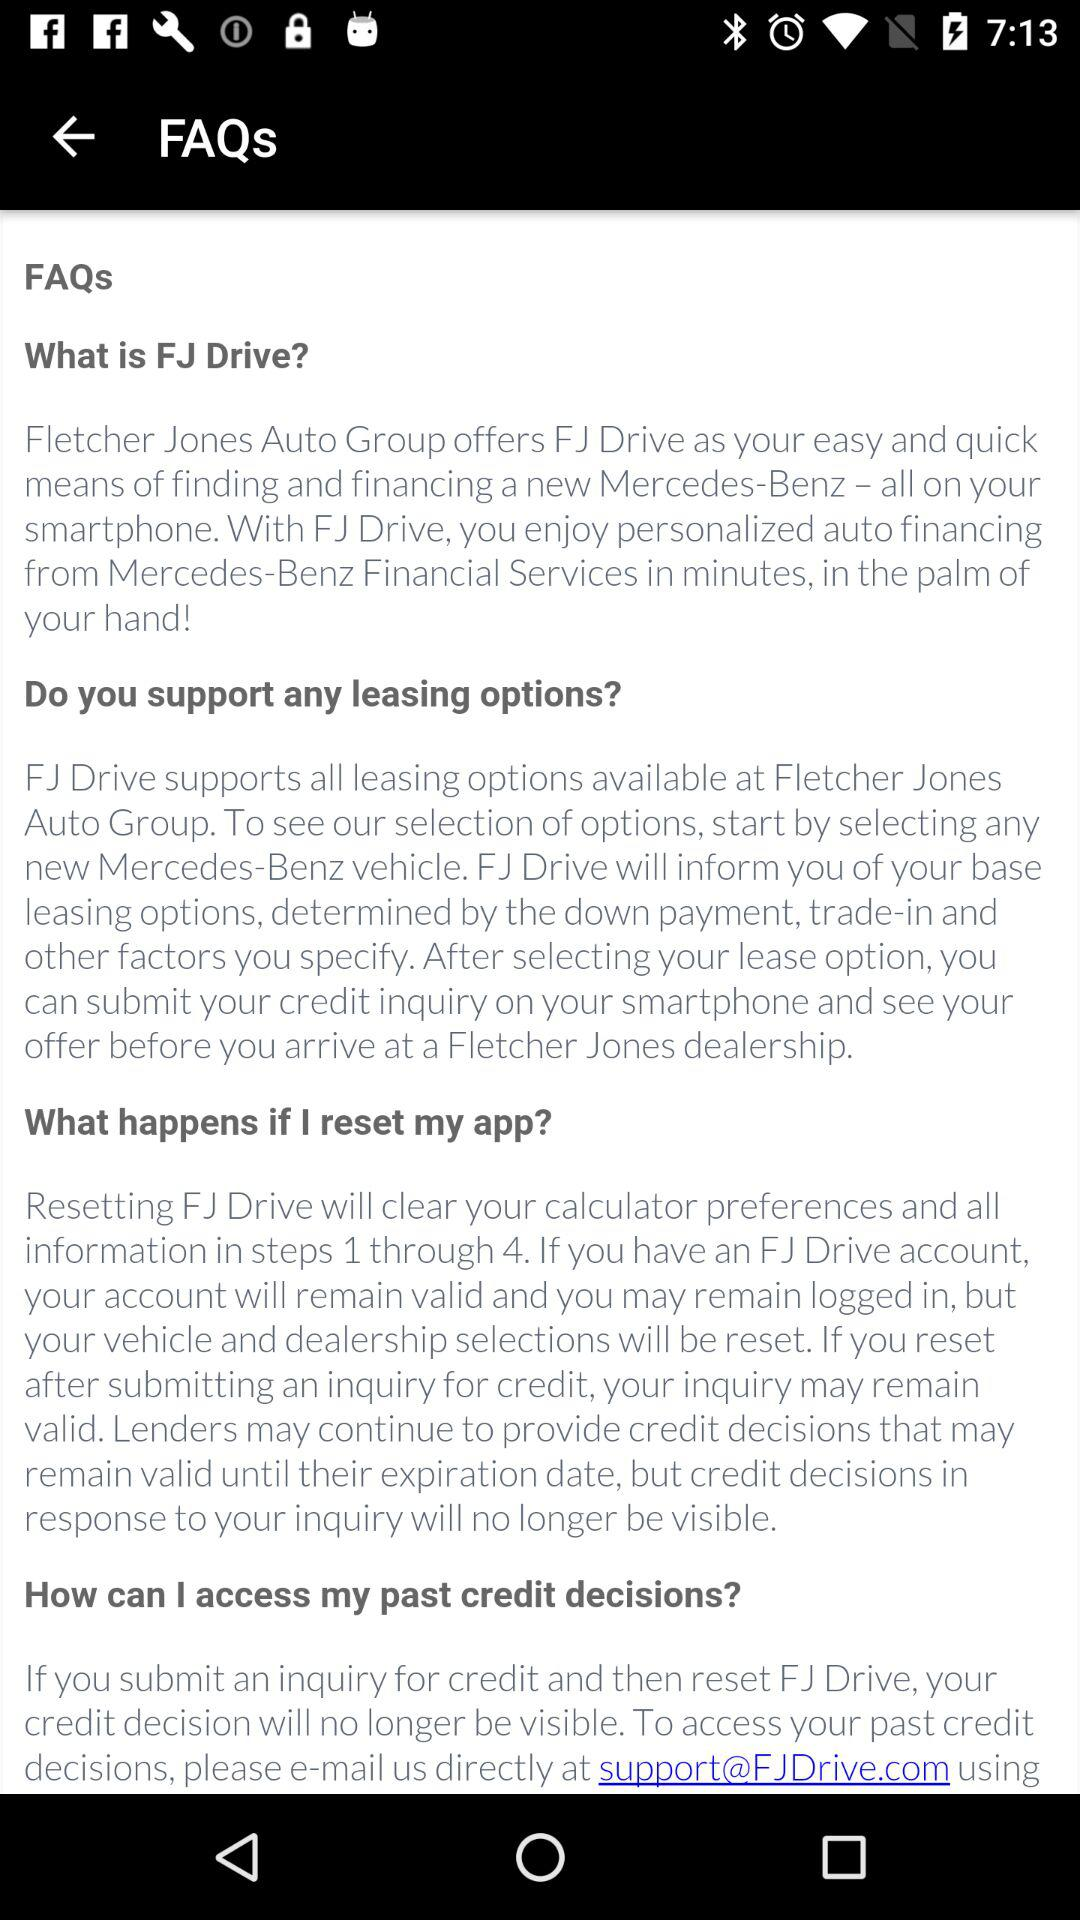How many questions are there in the FAQ section?
Answer the question using a single word or phrase. 4 